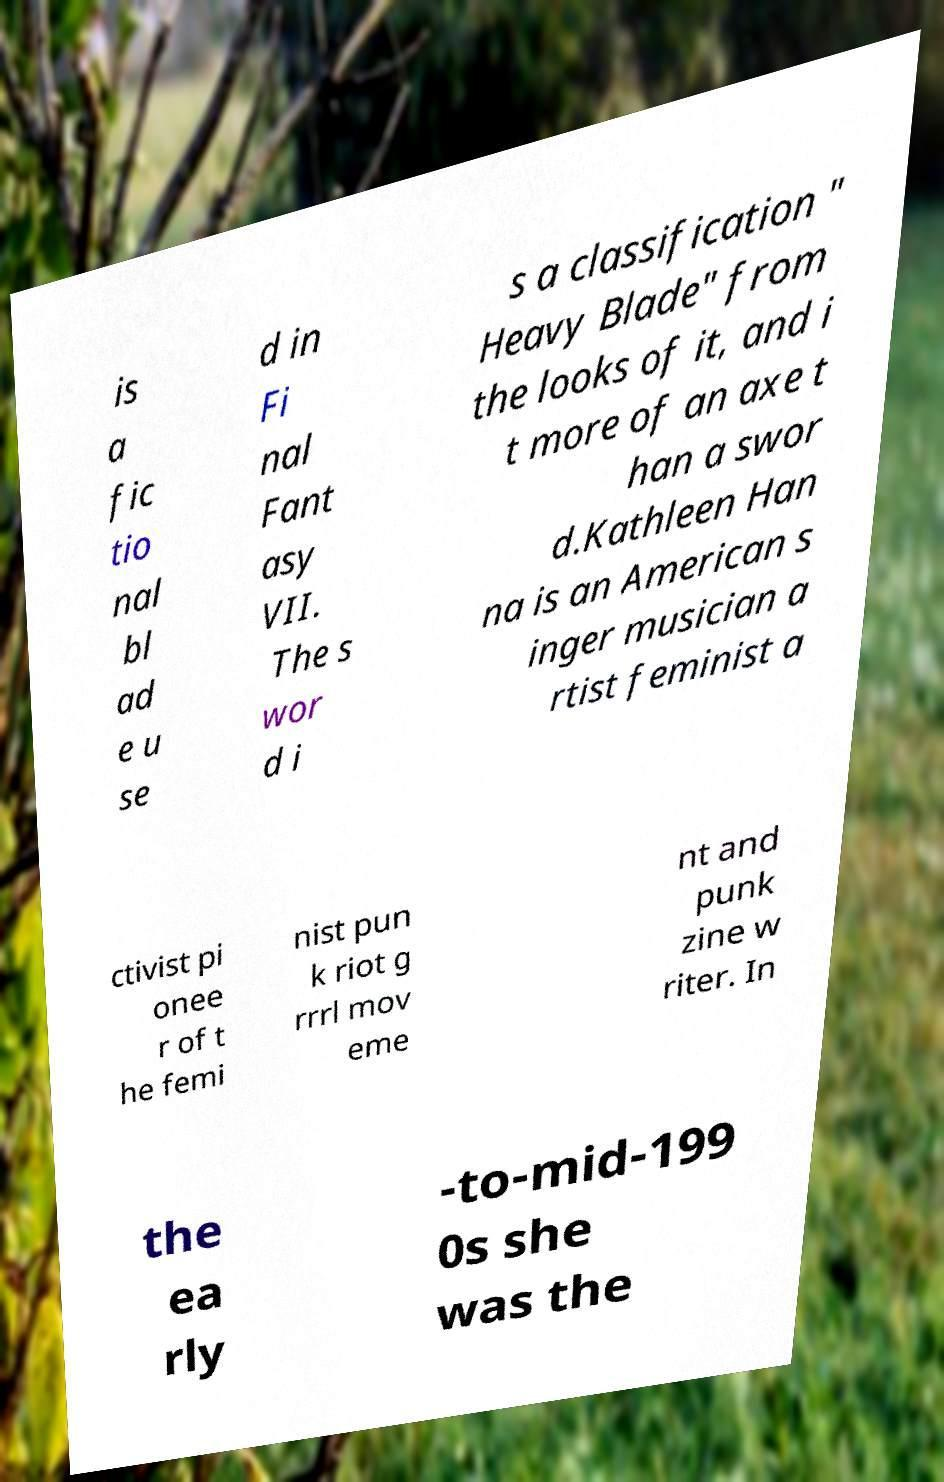For documentation purposes, I need the text within this image transcribed. Could you provide that? is a fic tio nal bl ad e u se d in Fi nal Fant asy VII. The s wor d i s a classification " Heavy Blade" from the looks of it, and i t more of an axe t han a swor d.Kathleen Han na is an American s inger musician a rtist feminist a ctivist pi onee r of t he femi nist pun k riot g rrrl mov eme nt and punk zine w riter. In the ea rly -to-mid-199 0s she was the 